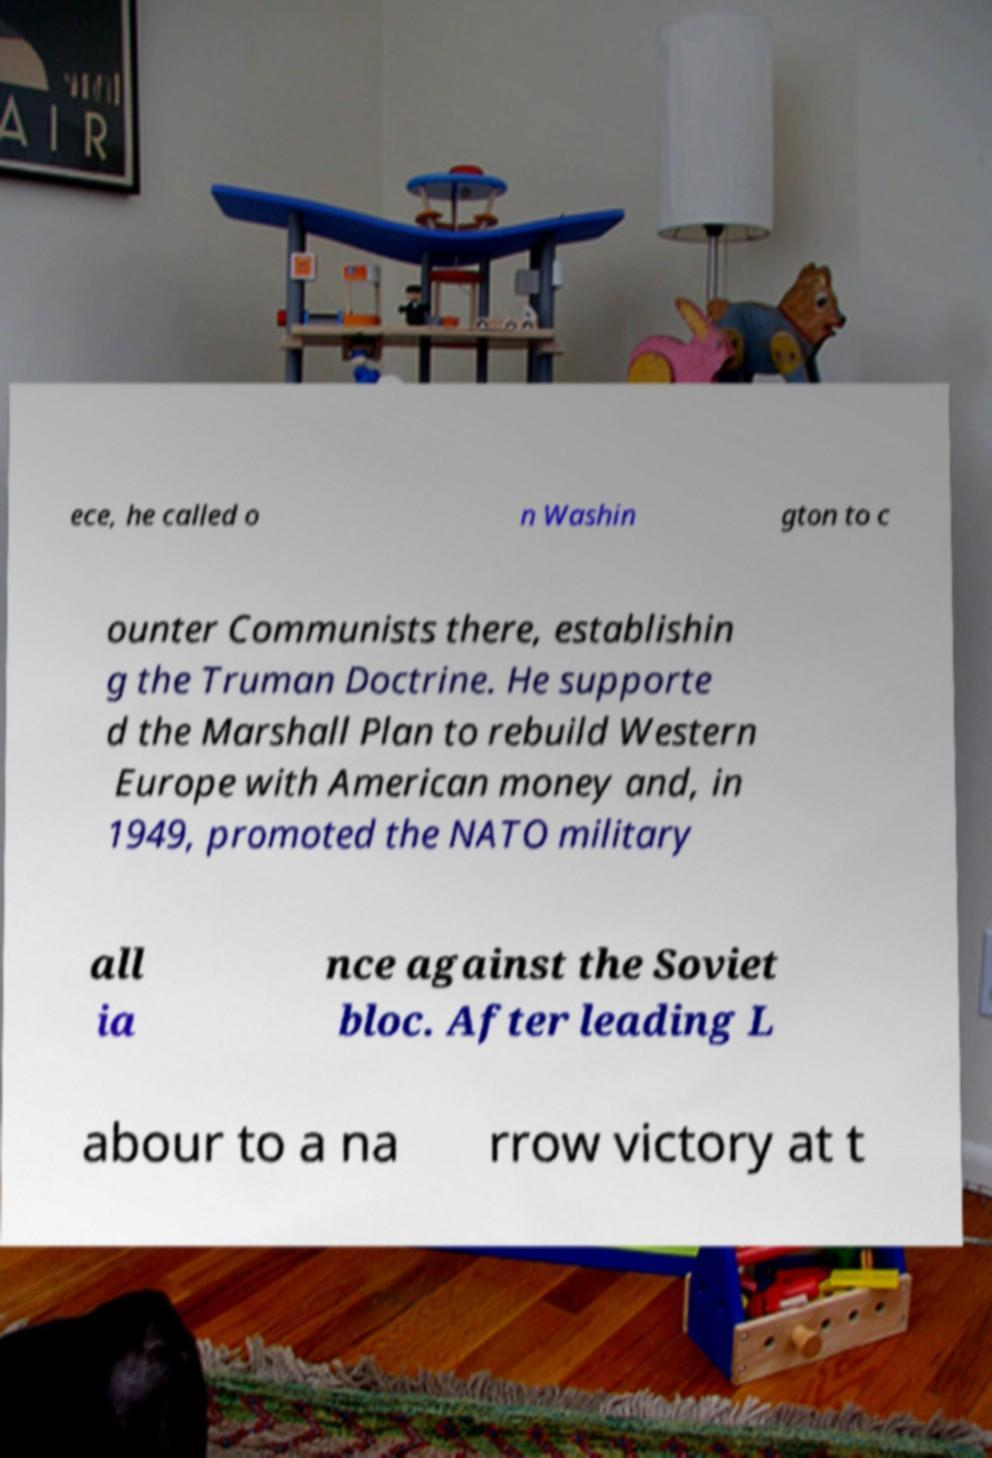What messages or text are displayed in this image? I need them in a readable, typed format. ece, he called o n Washin gton to c ounter Communists there, establishin g the Truman Doctrine. He supporte d the Marshall Plan to rebuild Western Europe with American money and, in 1949, promoted the NATO military all ia nce against the Soviet bloc. After leading L abour to a na rrow victory at t 